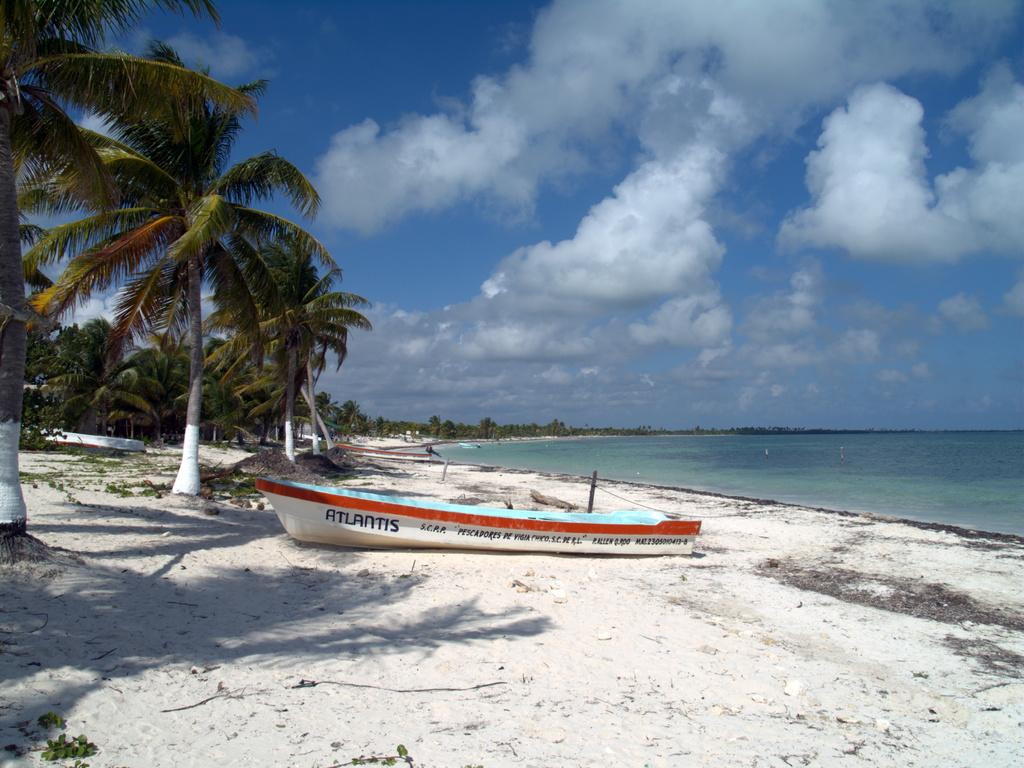What is the main subject of the image? The main subject of the image is a boat. What can be seen on the right side of the image? There is water on the right side of the image. What type of vegetation is on the left side of the image? There are trees on the left side of the image. What is visible at the top of the image? The sky is visible at the top of the image. Where is the fireman working on the farm in the image? There is no fireman or farm present in the image; it features a boat and its surroundings. What type of finger can be seen pointing at the boat in the image? There are no fingers visible in the image; it only shows a boat, water, trees, and the sky. 